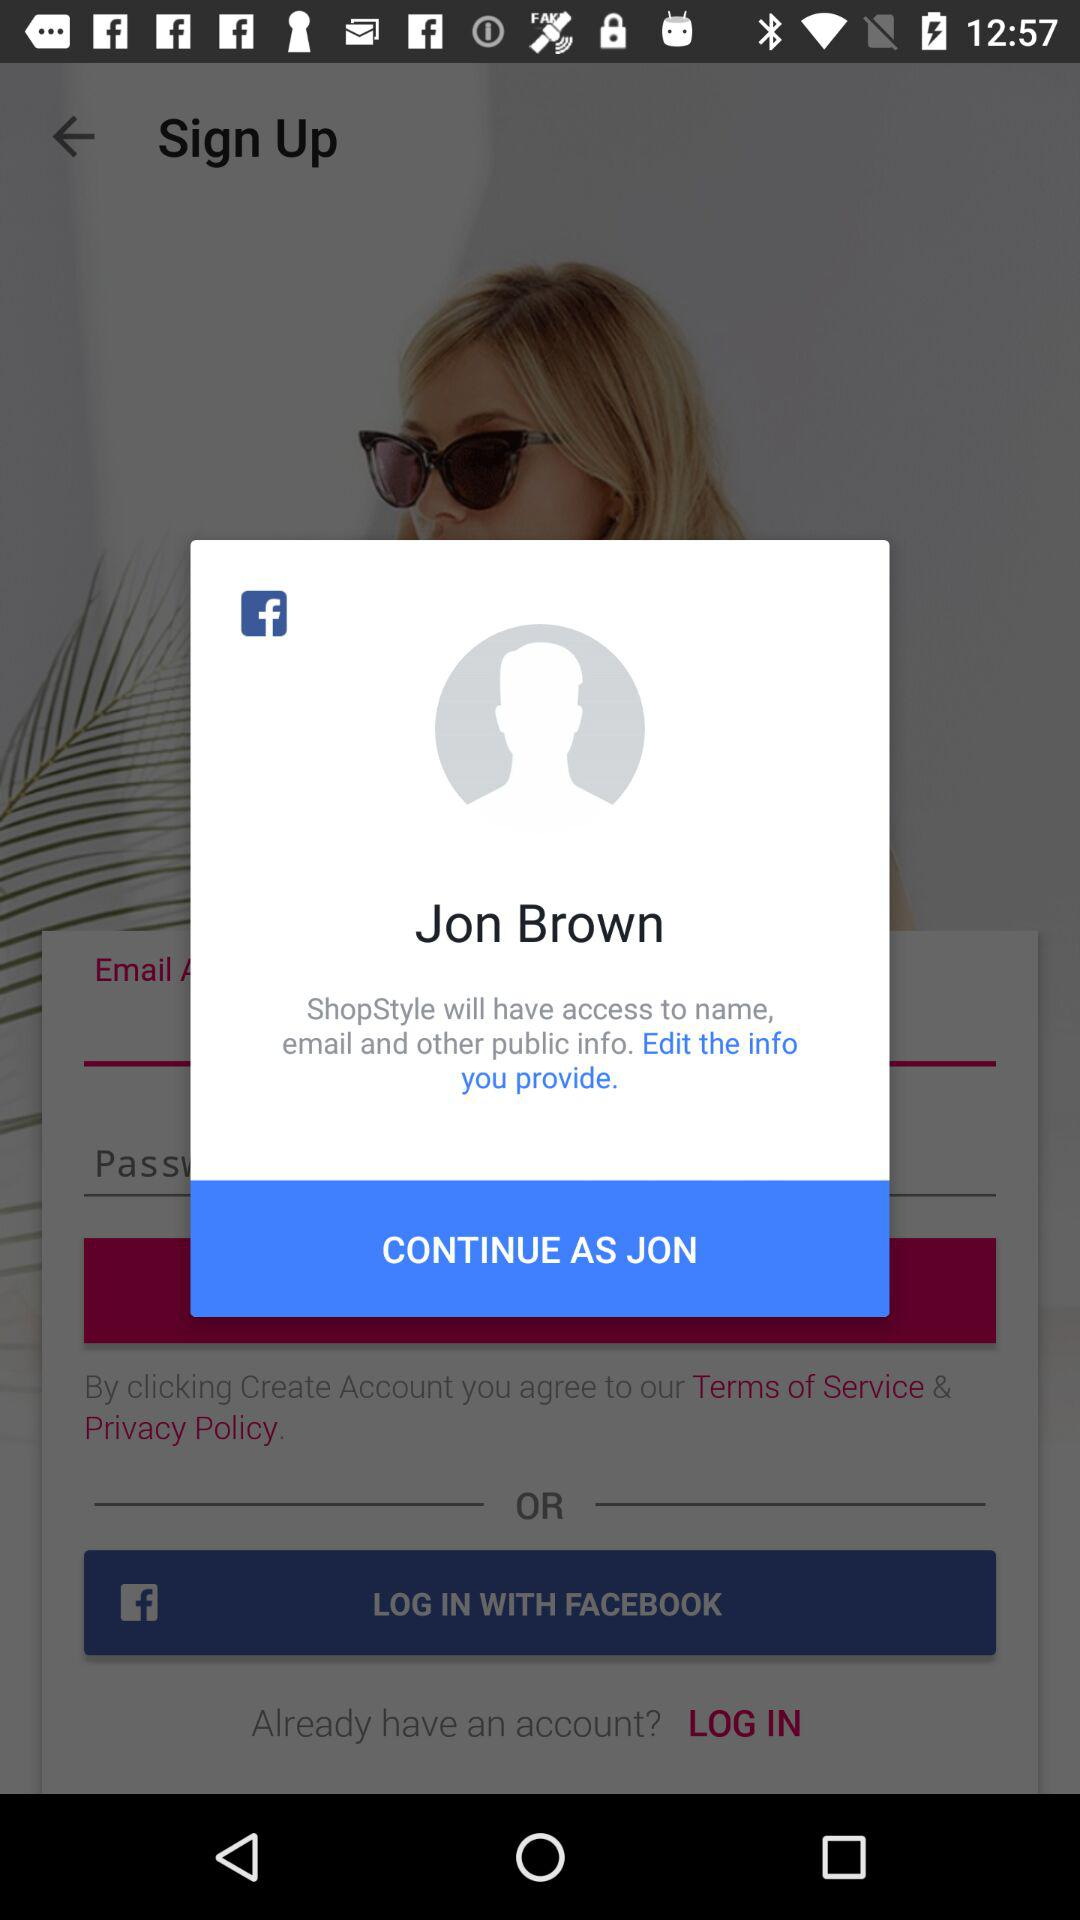What is the name of the user? The name of the user is Jon Brown. 